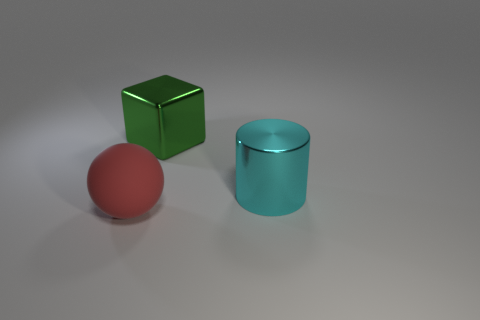There is a green object that is the same material as the cyan cylinder; what shape is it?
Offer a terse response. Cube. Are there fewer red matte balls behind the rubber object than gray matte spheres?
Provide a short and direct response. No. There is a shiny object that is in front of the metal block; what color is it?
Offer a terse response. Cyan. How many other green objects have the same shape as the matte thing?
Keep it short and to the point. 0. Are there fewer large cyan cylinders than large gray rubber cylinders?
Your answer should be very brief. No. There is a thing that is behind the large metal cylinder; what material is it?
Provide a succinct answer. Metal. There is a red object that is the same size as the shiny cylinder; what is it made of?
Your answer should be compact. Rubber. What is the material of the thing right of the metallic object that is to the left of the large metallic thing in front of the green shiny object?
Provide a short and direct response. Metal. There is a metallic object that is in front of the green metal object; does it have the same size as the big rubber thing?
Ensure brevity in your answer.  Yes. Is the number of cyan cylinders greater than the number of objects?
Make the answer very short. No. 